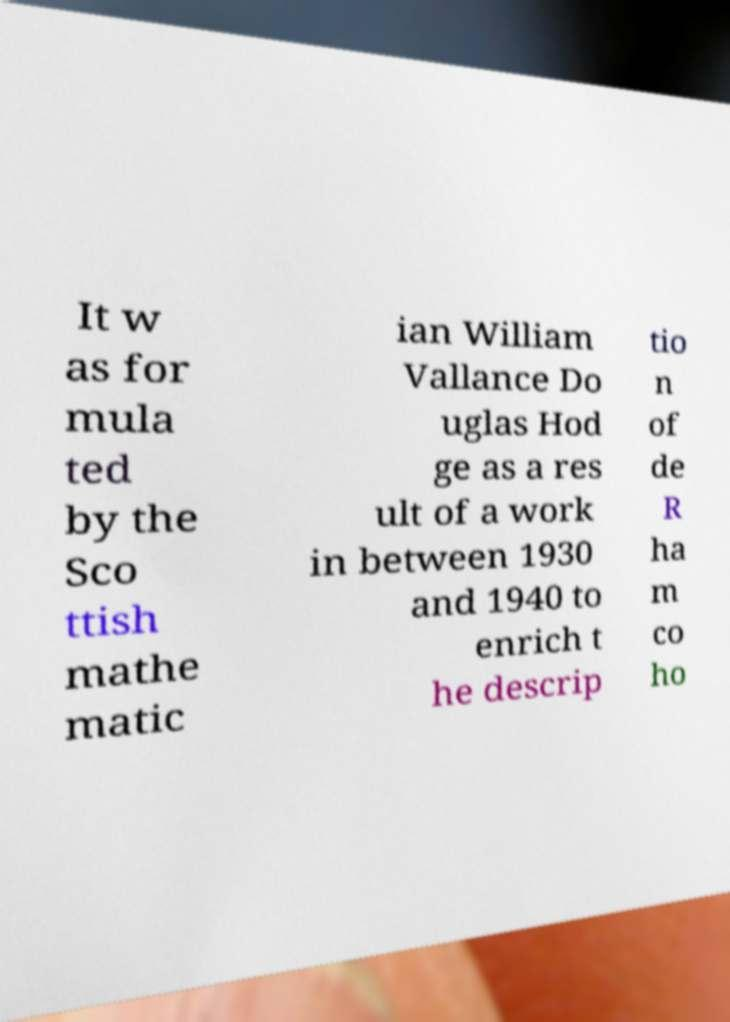For documentation purposes, I need the text within this image transcribed. Could you provide that? It w as for mula ted by the Sco ttish mathe matic ian William Vallance Do uglas Hod ge as a res ult of a work in between 1930 and 1940 to enrich t he descrip tio n of de R ha m co ho 